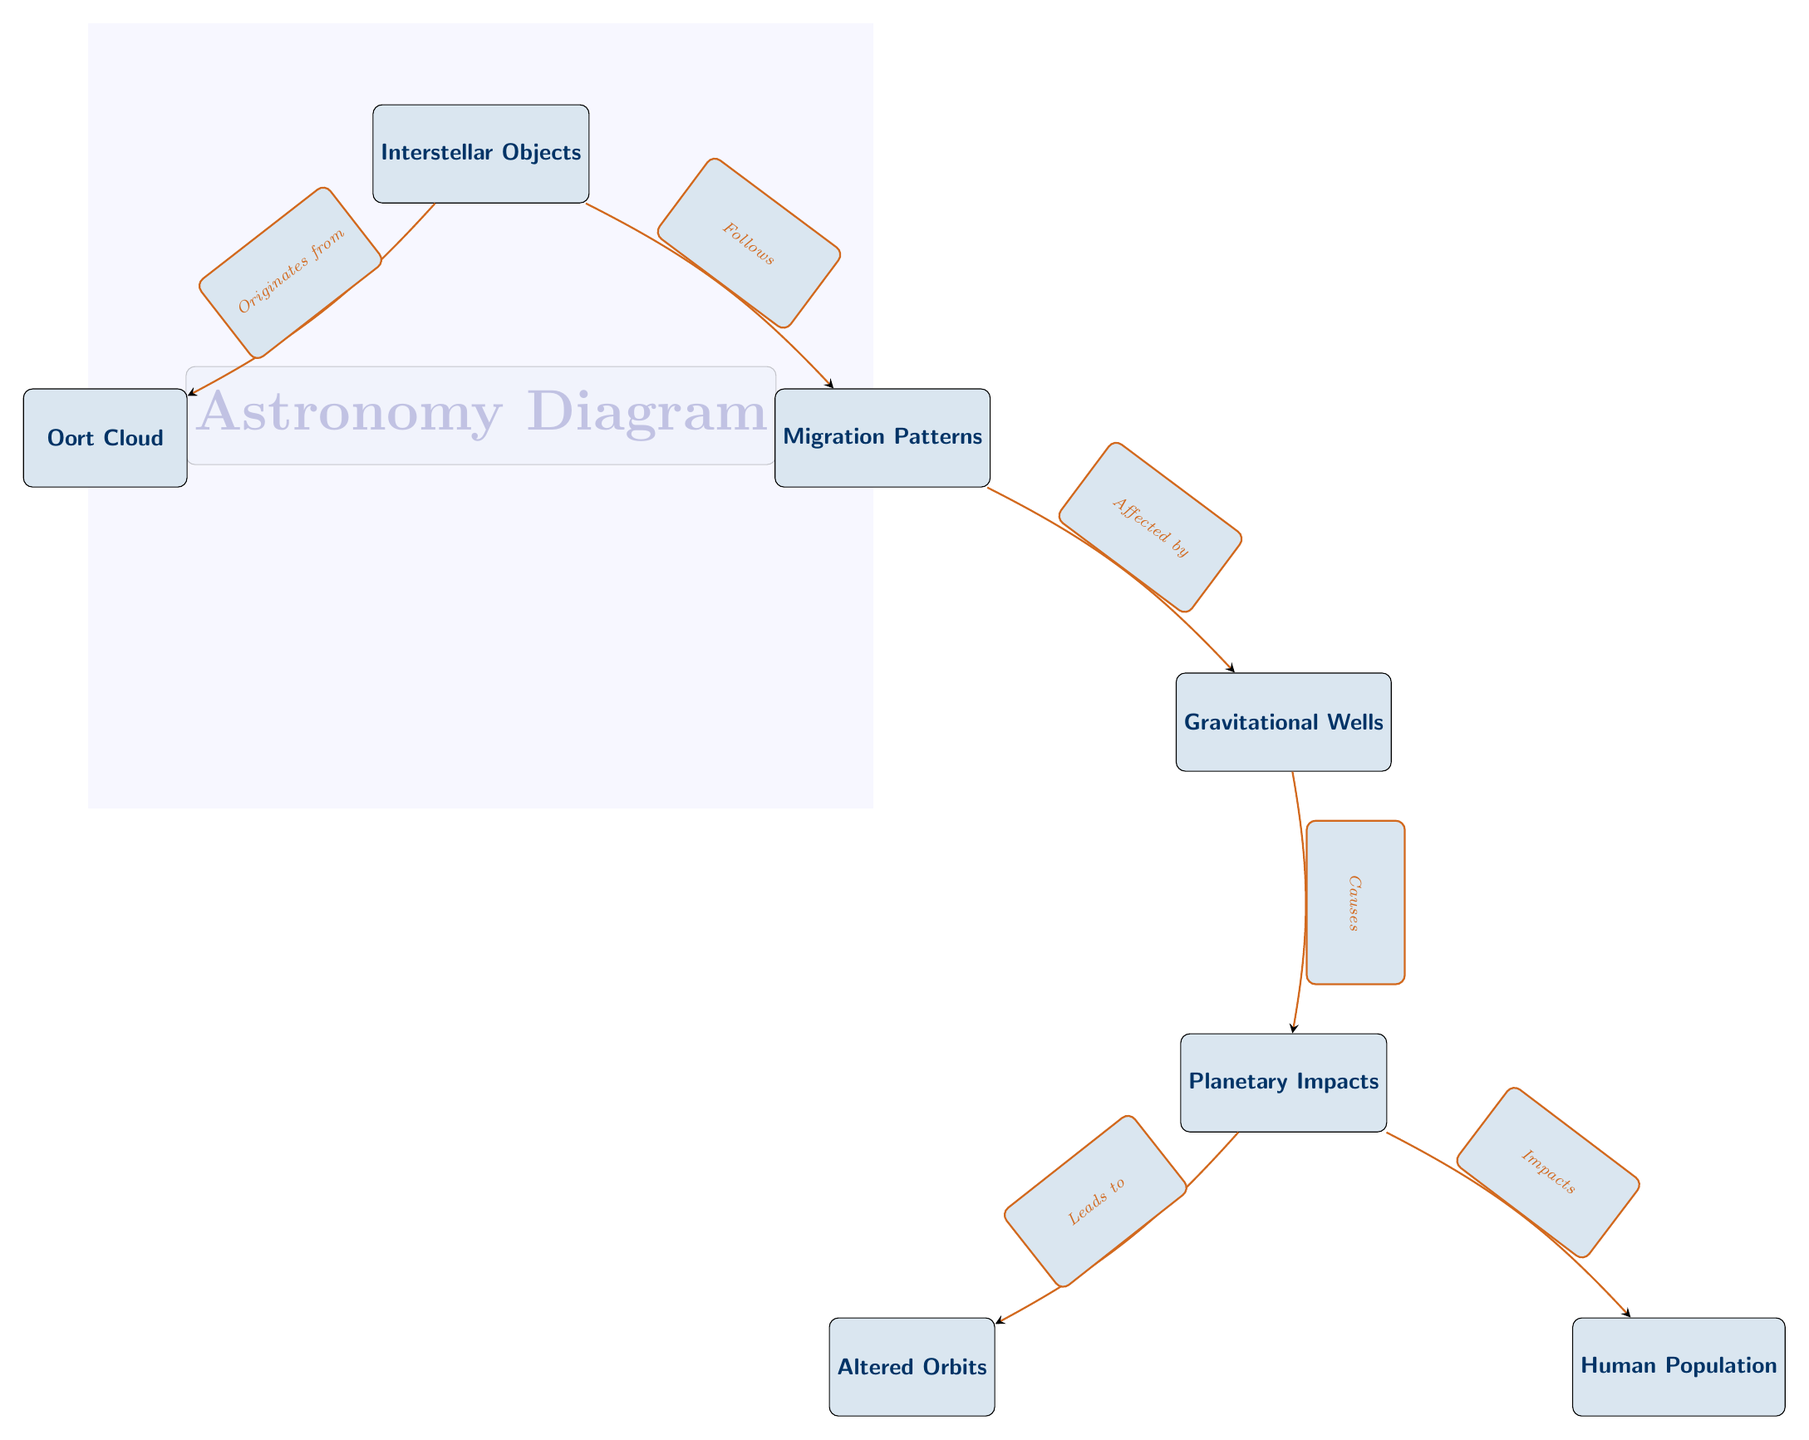What is the origin of interstellar objects? The diagram indicates that interstellar objects originate from the Oort Cloud, which is explicitly labeled and connected to the node for interstellar objects with a directed edge.
Answer: Oort Cloud How many nodes are shown in the diagram? By counting the clearly defined nodes in the diagram, we find a total of six distinct nodes: Interstellar Objects, Oort Cloud, Migration Patterns, Gravitational Wells, Planetary Impacts, and Human Population.
Answer: 6 What do migration patterns affect? The diagram shows that migration patterns are affected by gravitational wells, evidenced by the connecting arrow indicating a direct relationship from Migration Patterns to Gravitational Wells.
Answer: Gravitational Wells What does planetary impact lead to? According to the diagram, planetary impacts lead to altered orbits, as illustrated by the directed edge from Planetary Impacts to Altered Orbits.
Answer: Altered Orbits What is caused by gravitational wells? The diagram denotes that gravitational wells cause planetary impacts, as shown by the arrow indicating that gravitational wells lead to this effect.
Answer: Planetary Impacts Which node impacts human population? The diagram clearly indicates that planetary impacts have an effect on human population, as shown by the directed edge from Planetary Impacts to Human Population.
Answer: Human Population What relationship describes interstellar objects and migration patterns? Interstellar objects follow migration patterns, as indicated by the directed edge connecting these two nodes in the diagram.
Answer: Follows What type of impacts does migration from gravitational wells have? The interstellar object migration patterns cause planetary impacts, which lead to various effects; the relationship shown in the diagram indicates this causative influence.
Answer: Causes What is the primary subject of this astronomy diagram? The primary subject represented in the diagram is the migration patterns of interstellar objects and their subsequent effects on various planetary systems, as seen in the layout and labels of the nodes.
Answer: Migration patterns of interstellar objects and their impact on planetary systems 